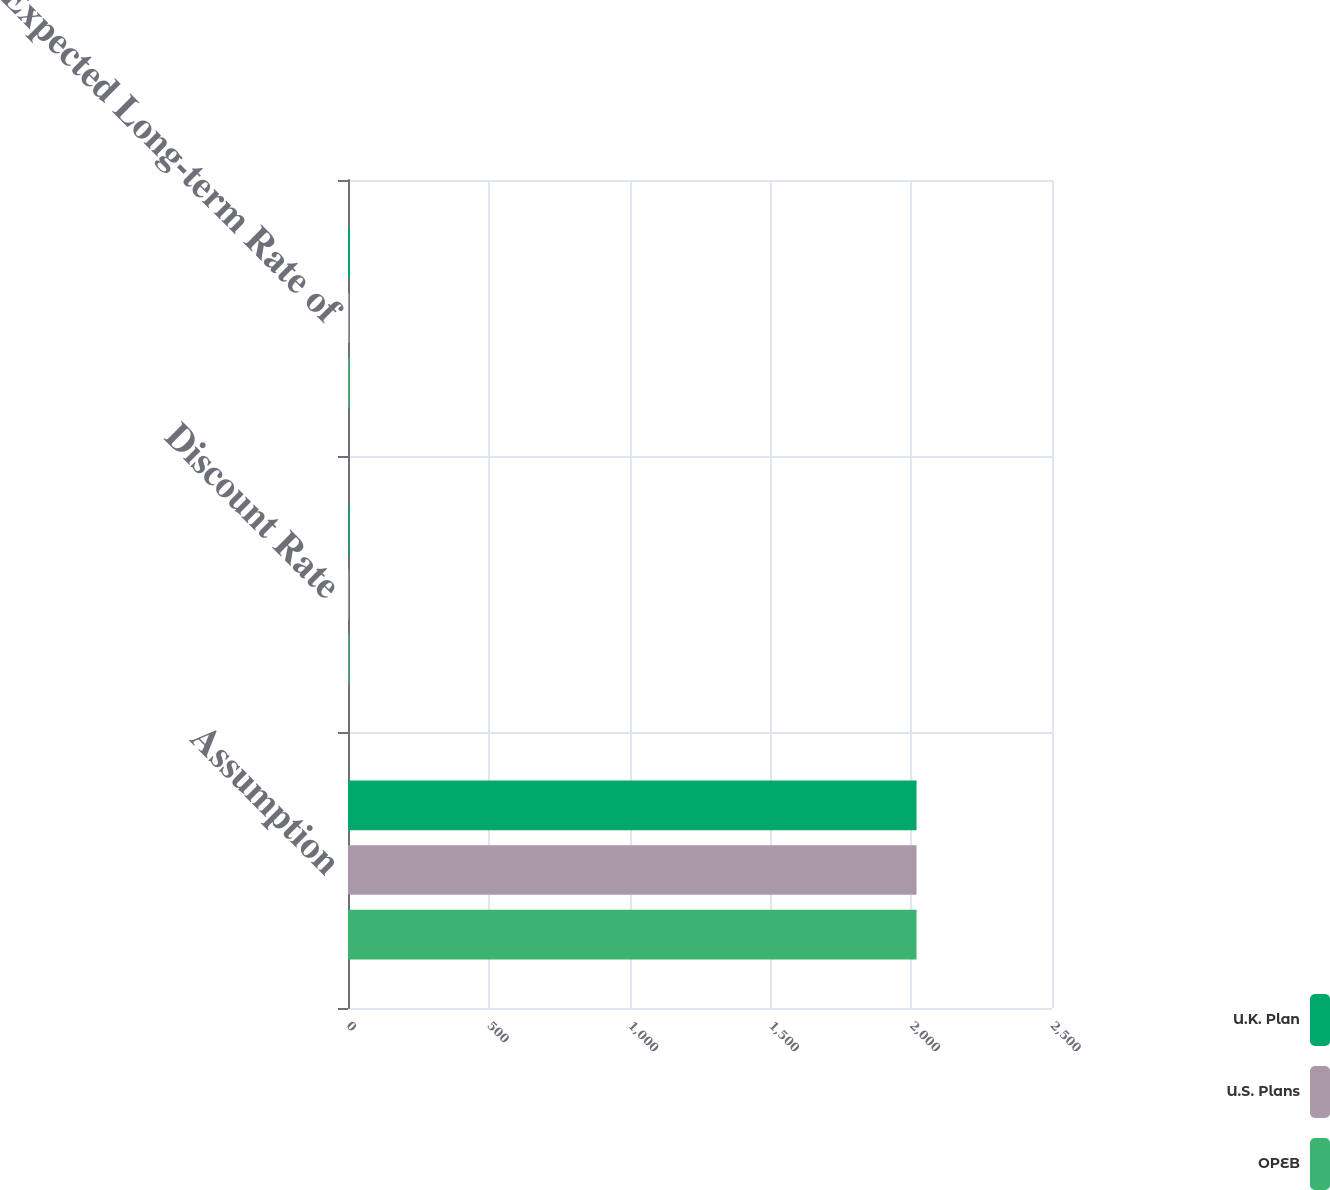Convert chart to OTSL. <chart><loc_0><loc_0><loc_500><loc_500><stacked_bar_chart><ecel><fcel>Assumption<fcel>Discount Rate<fcel>Expected Long-term Rate of<nl><fcel>U.K. Plan<fcel>2019<fcel>4.4<fcel>7<nl><fcel>U.S. Plans<fcel>2019<fcel>2.9<fcel>4.3<nl><fcel>OPEB<fcel>2019<fcel>4.4<fcel>5.75<nl></chart> 